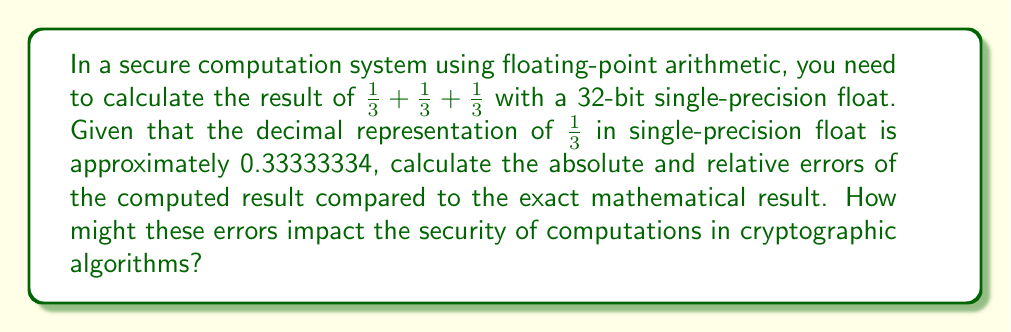Can you answer this question? To solve this problem, we need to follow these steps:

1) First, let's calculate the exact mathematical result:
   $$\frac{1}{3} + \frac{1}{3} + \frac{1}{3} = 1$$

2) Now, let's calculate the result using single-precision floats:
   $$0.33333334 + 0.33333334 + 0.33333334 = 1.00000002$$

3) To calculate the absolute error, we use the formula:
   $$\text{Absolute Error} = |\text{Approximate Value} - \text{Exact Value}|$$
   $$\text{Absolute Error} = |1.00000002 - 1| = 0.00000002$$

4) To calculate the relative error, we use the formula:
   $$\text{Relative Error} = \frac{|\text{Approximate Value} - \text{Exact Value}|}{|\text{Exact Value}|}$$
   $$\text{Relative Error} = \frac{|1.00000002 - 1|}{|1|} = 0.00000002$$

5) Impact on security:
   These small errors can accumulate in complex cryptographic algorithms, potentially leading to:
   - Incorrect results in equality checks
   - Unexpected behavior in branching conditions
   - Vulnerabilities in timing-based side-channel attacks due to different execution paths
   - Inaccuracies in key generation or random number generation processes

   In secure systems, even small errors can be exploited by attackers. Therefore, it's crucial to understand and account for these floating-point inaccuracies in cryptographic implementations.
Answer: Absolute Error: 0.00000002
Relative Error: 0.00000002 (or 2e-8)

These errors, while small, can potentially impact the security of cryptographic computations by causing unexpected behaviors, inaccuracies in key generation, or vulnerabilities to side-channel attacks. 